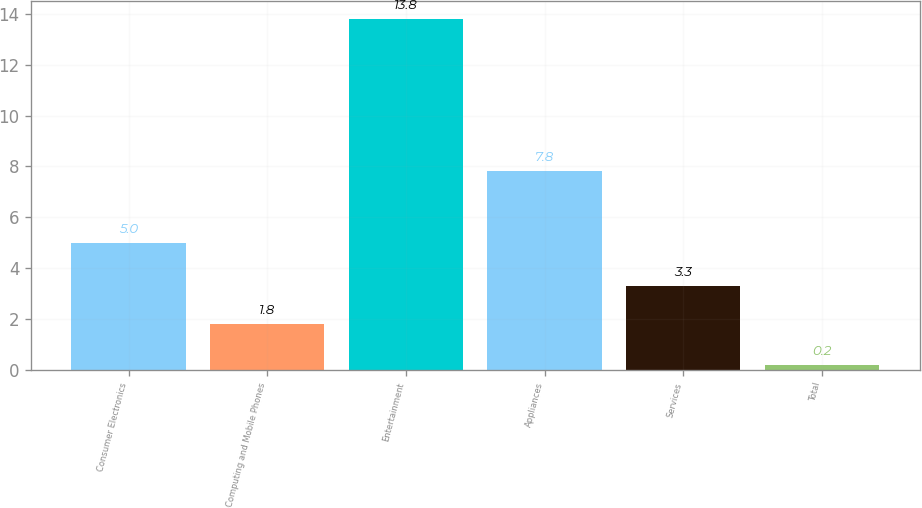Convert chart to OTSL. <chart><loc_0><loc_0><loc_500><loc_500><bar_chart><fcel>Consumer Electronics<fcel>Computing and Mobile Phones<fcel>Entertainment<fcel>Appliances<fcel>Services<fcel>Total<nl><fcel>5<fcel>1.8<fcel>13.8<fcel>7.8<fcel>3.3<fcel>0.2<nl></chart> 